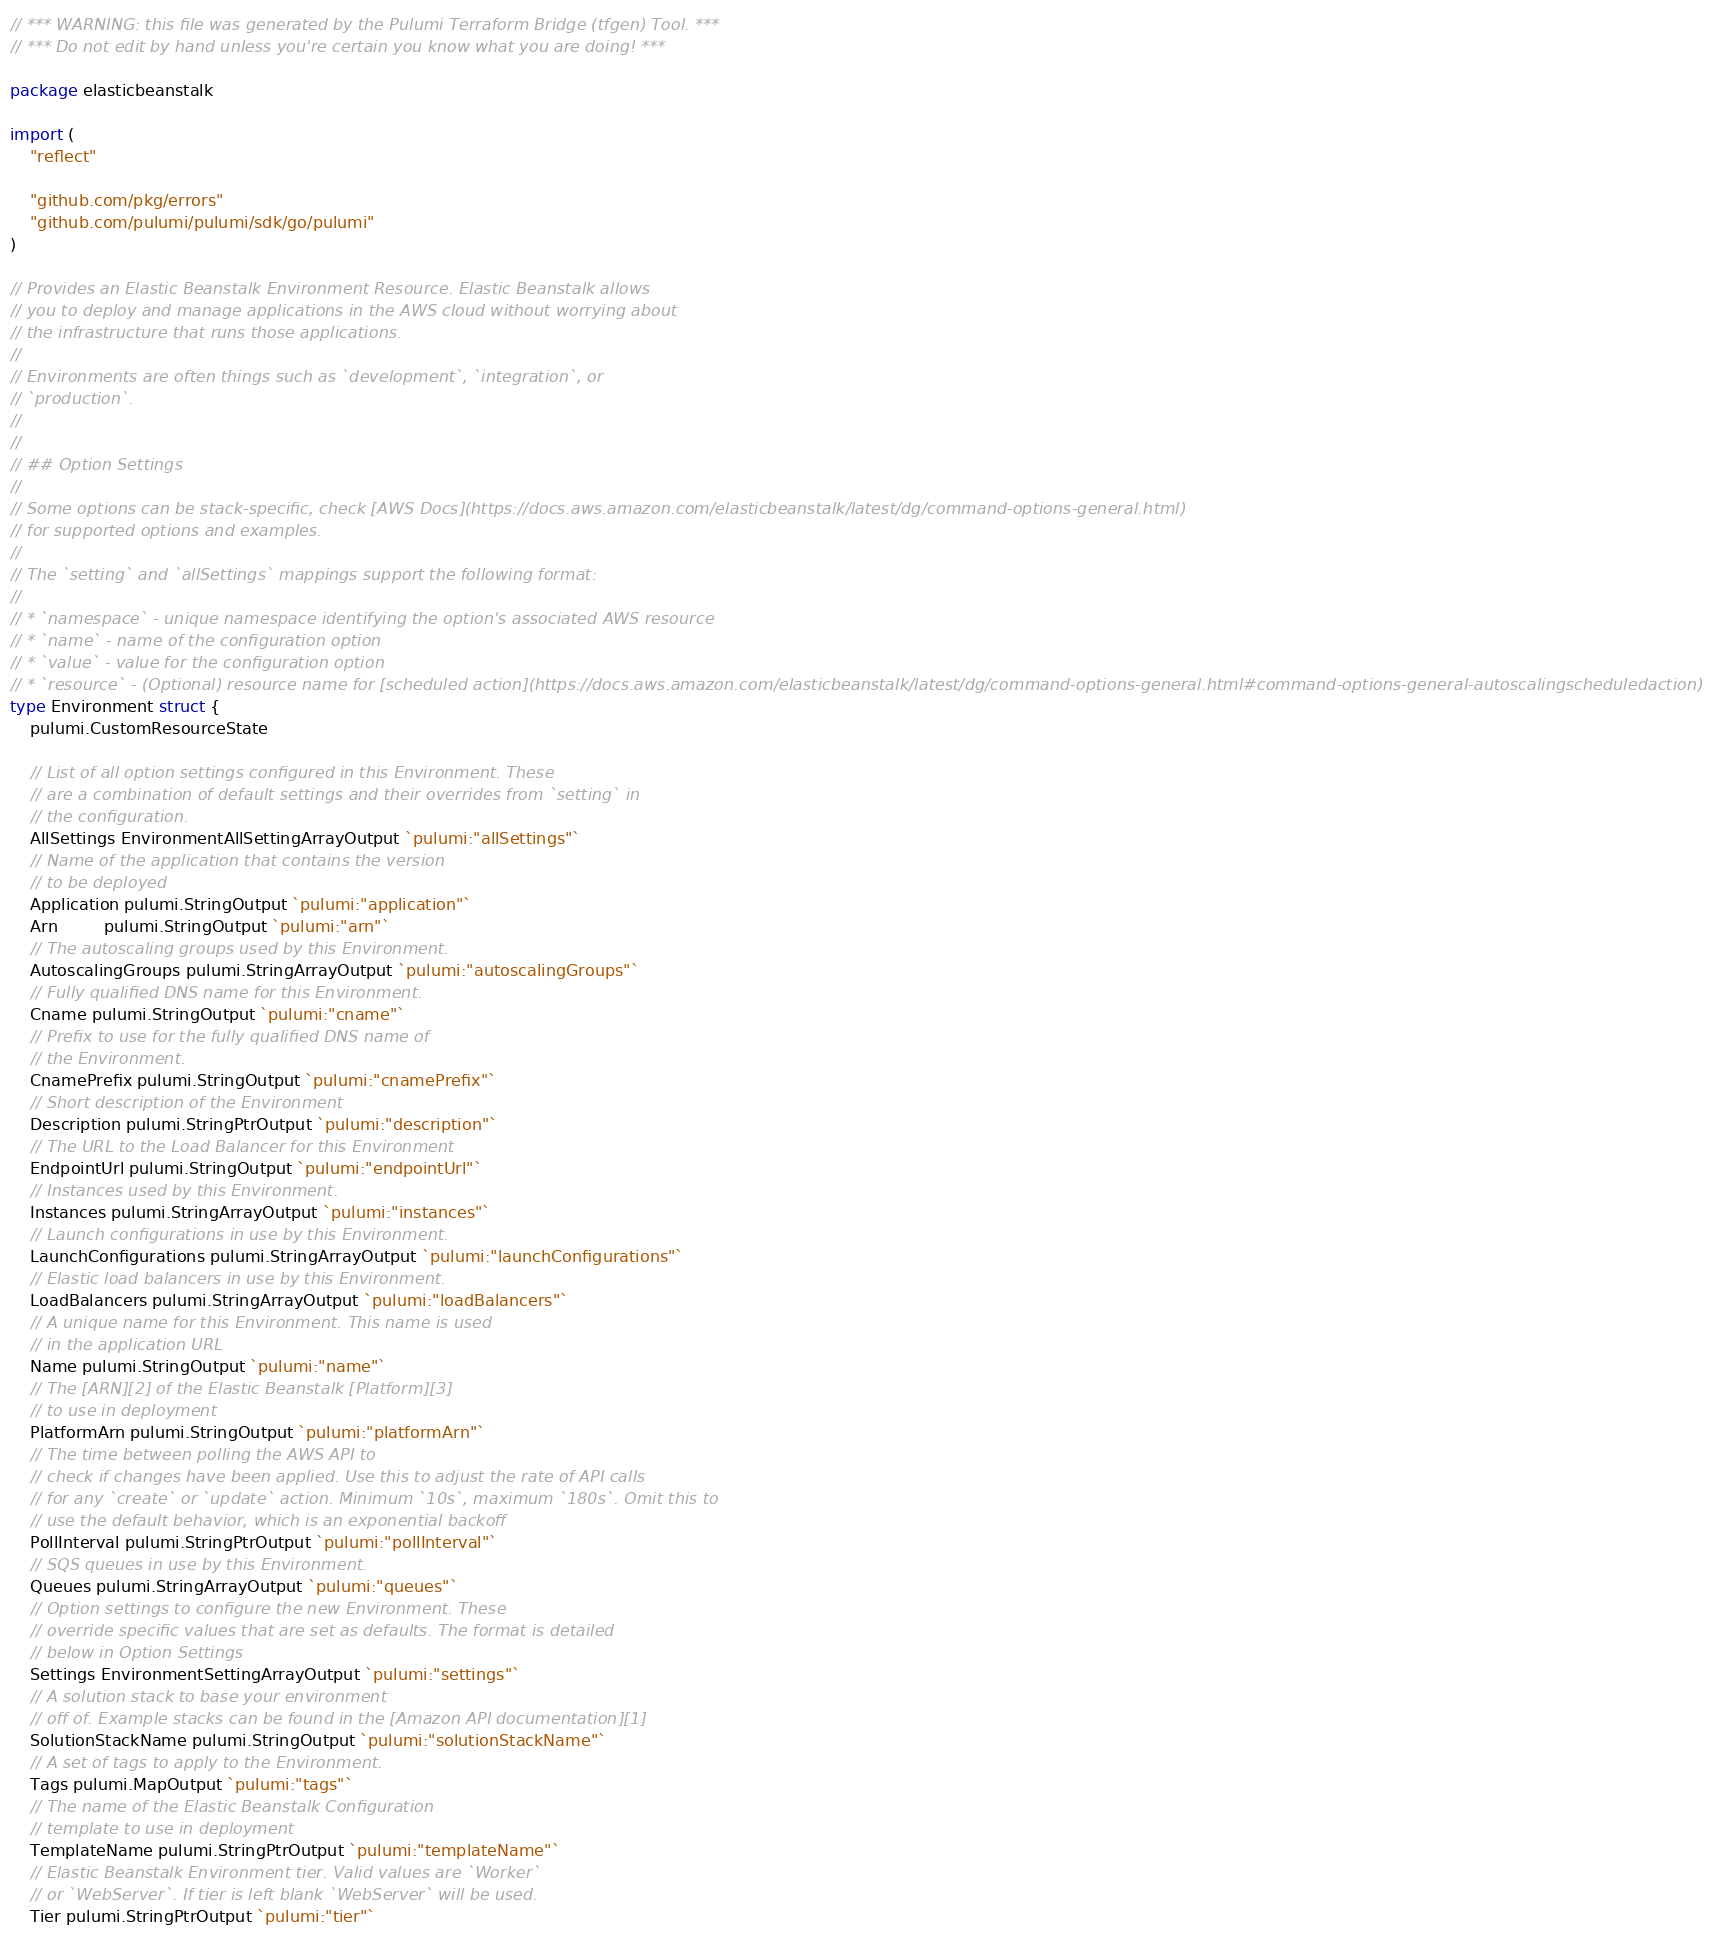Convert code to text. <code><loc_0><loc_0><loc_500><loc_500><_Go_>// *** WARNING: this file was generated by the Pulumi Terraform Bridge (tfgen) Tool. ***
// *** Do not edit by hand unless you're certain you know what you are doing! ***

package elasticbeanstalk

import (
	"reflect"

	"github.com/pkg/errors"
	"github.com/pulumi/pulumi/sdk/go/pulumi"
)

// Provides an Elastic Beanstalk Environment Resource. Elastic Beanstalk allows
// you to deploy and manage applications in the AWS cloud without worrying about
// the infrastructure that runs those applications.
//
// Environments are often things such as `development`, `integration`, or
// `production`.
//
//
// ## Option Settings
//
// Some options can be stack-specific, check [AWS Docs](https://docs.aws.amazon.com/elasticbeanstalk/latest/dg/command-options-general.html)
// for supported options and examples.
//
// The `setting` and `allSettings` mappings support the following format:
//
// * `namespace` - unique namespace identifying the option's associated AWS resource
// * `name` - name of the configuration option
// * `value` - value for the configuration option
// * `resource` - (Optional) resource name for [scheduled action](https://docs.aws.amazon.com/elasticbeanstalk/latest/dg/command-options-general.html#command-options-general-autoscalingscheduledaction)
type Environment struct {
	pulumi.CustomResourceState

	// List of all option settings configured in this Environment. These
	// are a combination of default settings and their overrides from `setting` in
	// the configuration.
	AllSettings EnvironmentAllSettingArrayOutput `pulumi:"allSettings"`
	// Name of the application that contains the version
	// to be deployed
	Application pulumi.StringOutput `pulumi:"application"`
	Arn         pulumi.StringOutput `pulumi:"arn"`
	// The autoscaling groups used by this Environment.
	AutoscalingGroups pulumi.StringArrayOutput `pulumi:"autoscalingGroups"`
	// Fully qualified DNS name for this Environment.
	Cname pulumi.StringOutput `pulumi:"cname"`
	// Prefix to use for the fully qualified DNS name of
	// the Environment.
	CnamePrefix pulumi.StringOutput `pulumi:"cnamePrefix"`
	// Short description of the Environment
	Description pulumi.StringPtrOutput `pulumi:"description"`
	// The URL to the Load Balancer for this Environment
	EndpointUrl pulumi.StringOutput `pulumi:"endpointUrl"`
	// Instances used by this Environment.
	Instances pulumi.StringArrayOutput `pulumi:"instances"`
	// Launch configurations in use by this Environment.
	LaunchConfigurations pulumi.StringArrayOutput `pulumi:"launchConfigurations"`
	// Elastic load balancers in use by this Environment.
	LoadBalancers pulumi.StringArrayOutput `pulumi:"loadBalancers"`
	// A unique name for this Environment. This name is used
	// in the application URL
	Name pulumi.StringOutput `pulumi:"name"`
	// The [ARN][2] of the Elastic Beanstalk [Platform][3]
	// to use in deployment
	PlatformArn pulumi.StringOutput `pulumi:"platformArn"`
	// The time between polling the AWS API to
	// check if changes have been applied. Use this to adjust the rate of API calls
	// for any `create` or `update` action. Minimum `10s`, maximum `180s`. Omit this to
	// use the default behavior, which is an exponential backoff
	PollInterval pulumi.StringPtrOutput `pulumi:"pollInterval"`
	// SQS queues in use by this Environment.
	Queues pulumi.StringArrayOutput `pulumi:"queues"`
	// Option settings to configure the new Environment. These
	// override specific values that are set as defaults. The format is detailed
	// below in Option Settings
	Settings EnvironmentSettingArrayOutput `pulumi:"settings"`
	// A solution stack to base your environment
	// off of. Example stacks can be found in the [Amazon API documentation][1]
	SolutionStackName pulumi.StringOutput `pulumi:"solutionStackName"`
	// A set of tags to apply to the Environment.
	Tags pulumi.MapOutput `pulumi:"tags"`
	// The name of the Elastic Beanstalk Configuration
	// template to use in deployment
	TemplateName pulumi.StringPtrOutput `pulumi:"templateName"`
	// Elastic Beanstalk Environment tier. Valid values are `Worker`
	// or `WebServer`. If tier is left blank `WebServer` will be used.
	Tier pulumi.StringPtrOutput `pulumi:"tier"`</code> 